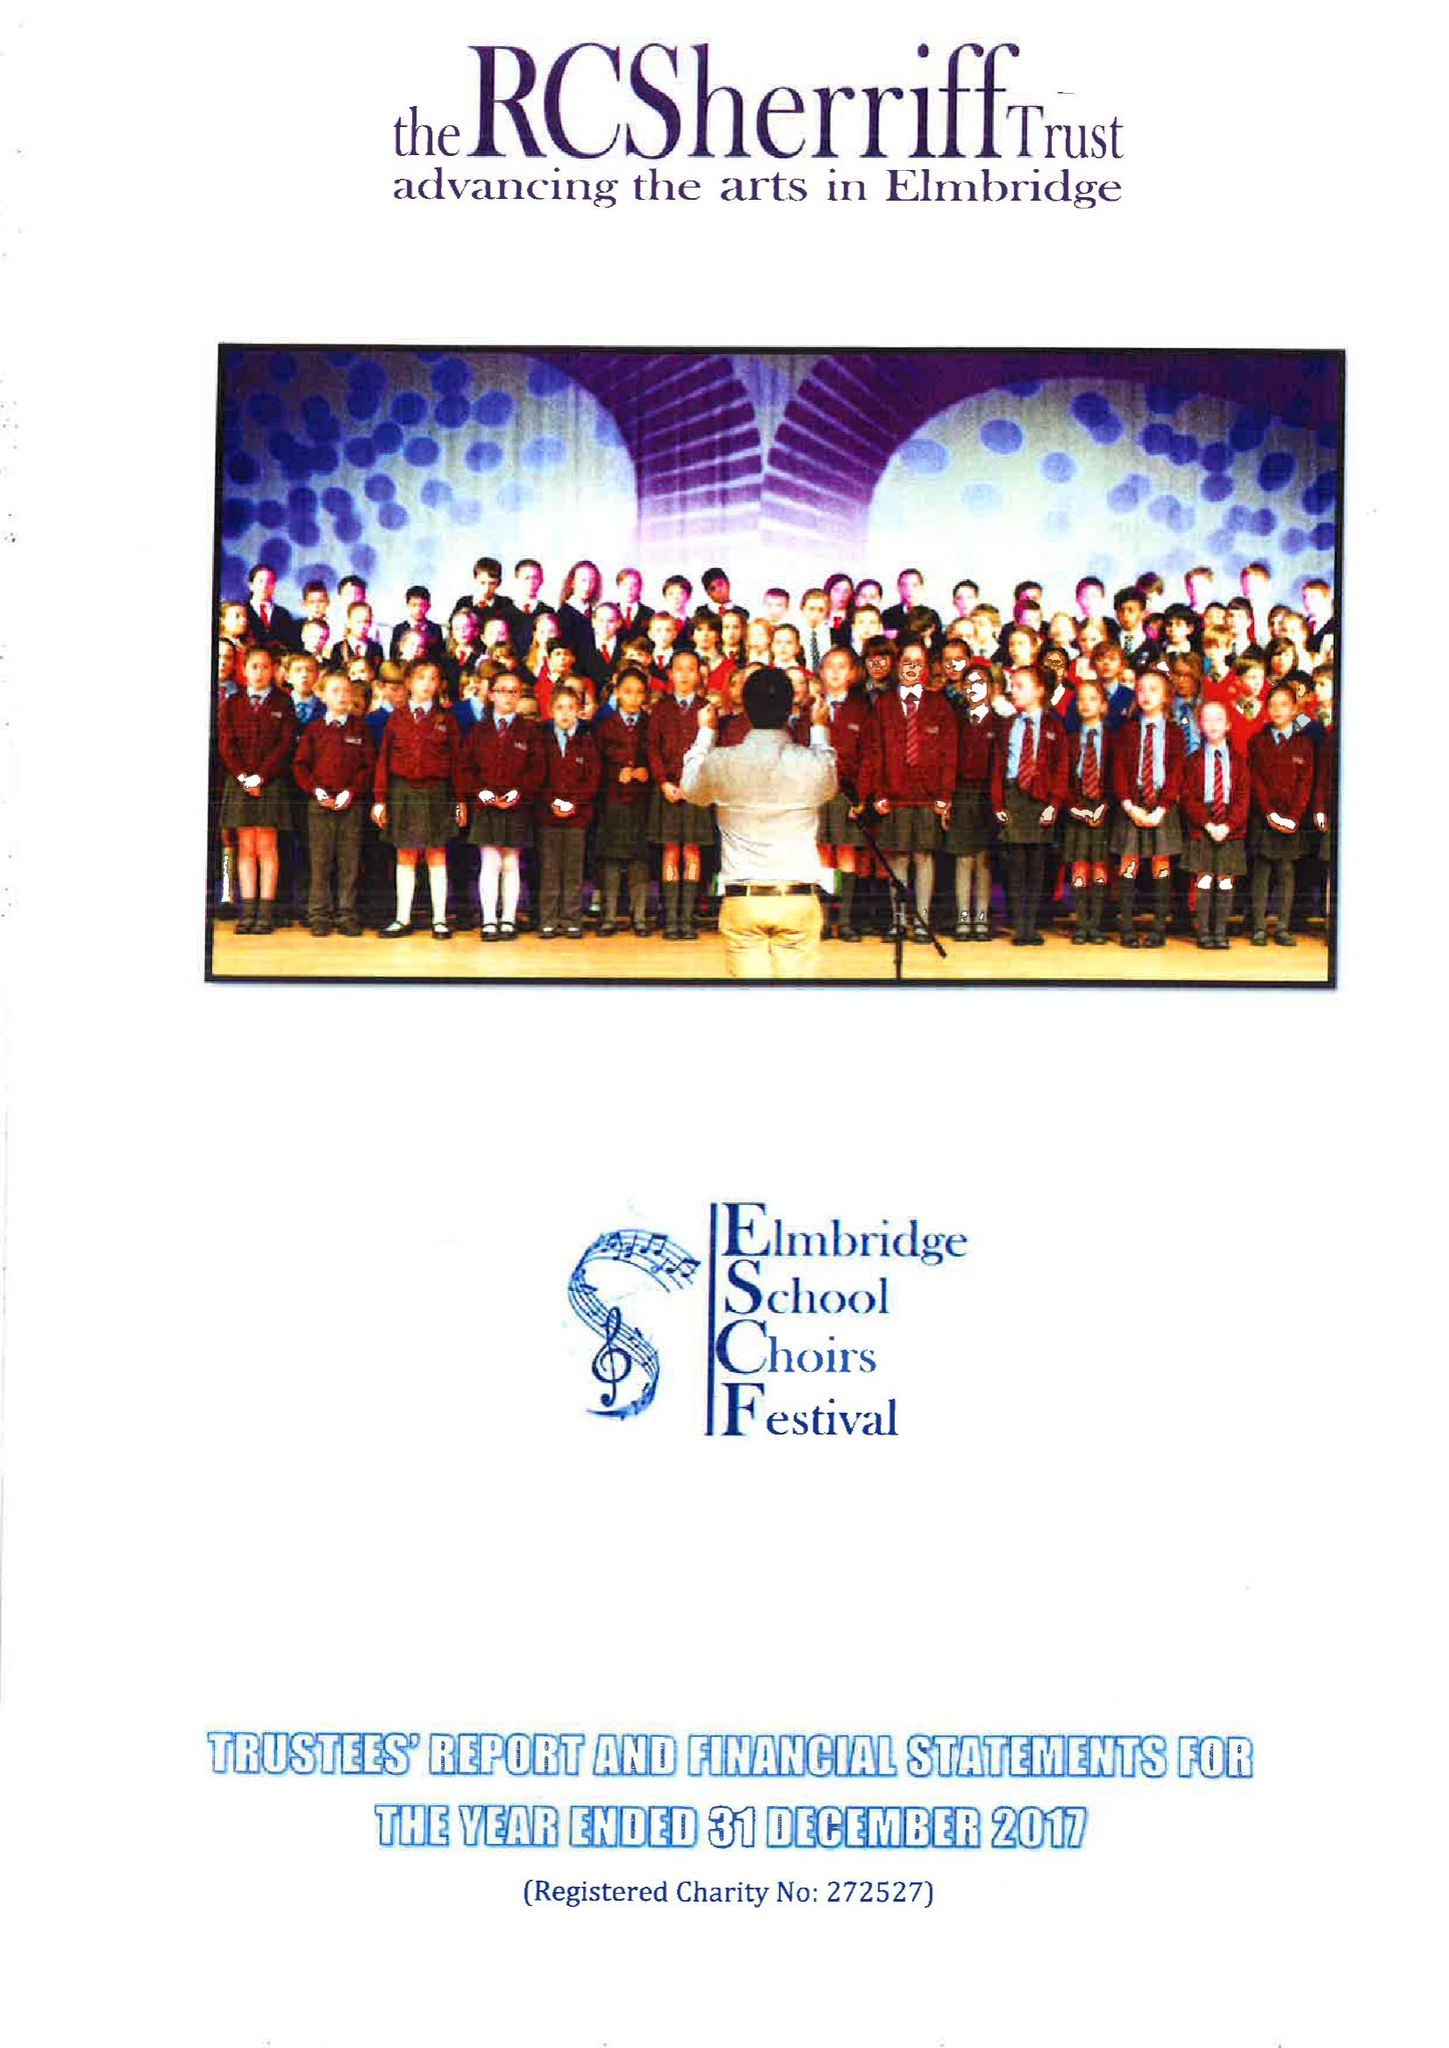What is the value for the charity_number?
Answer the question using a single word or phrase. 272527 